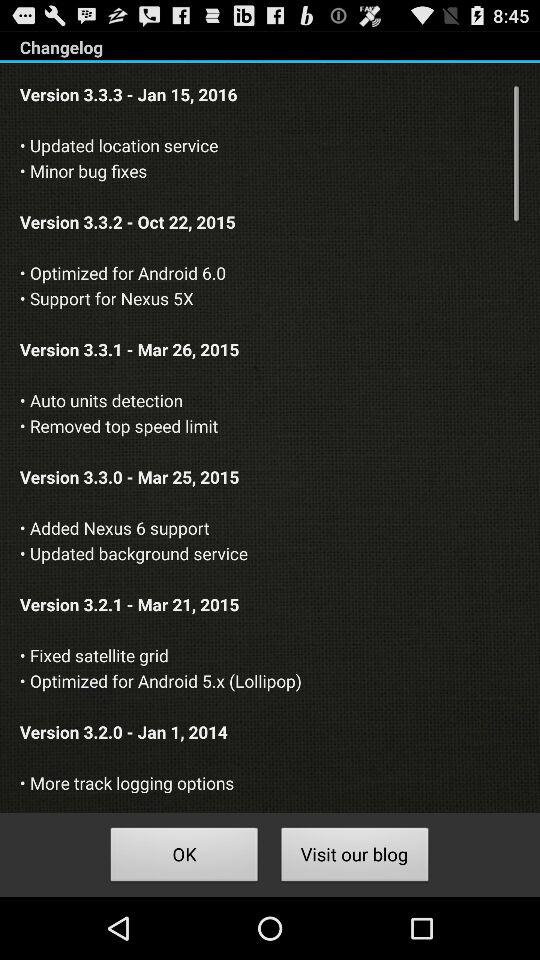Which version fixes minor bugs? The version that fixes minor bugs is 3.3.3. 